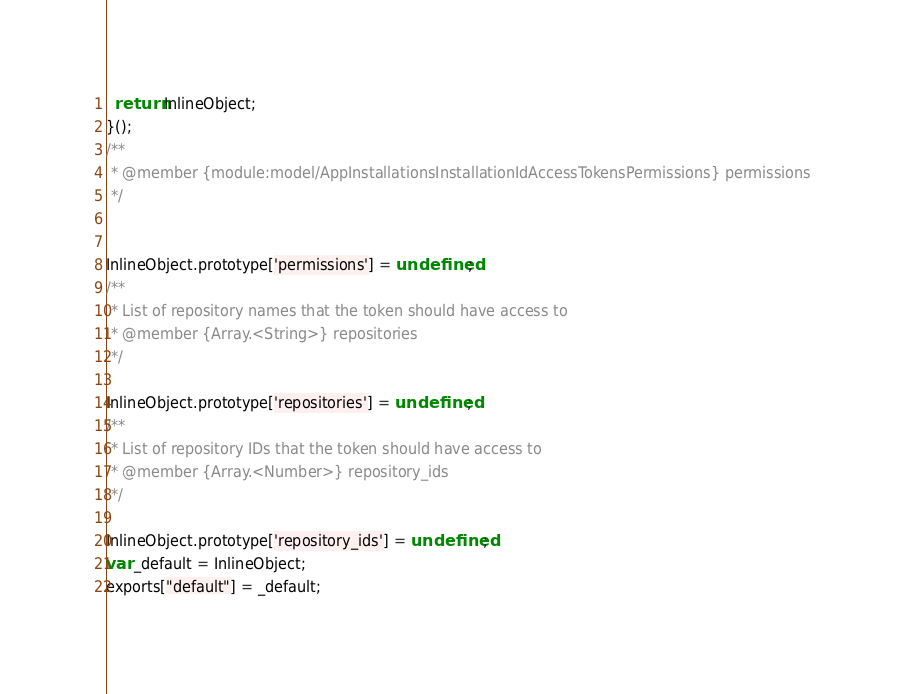Convert code to text. <code><loc_0><loc_0><loc_500><loc_500><_JavaScript_>
  return InlineObject;
}();
/**
 * @member {module:model/AppInstallationsInstallationIdAccessTokensPermissions} permissions
 */


InlineObject.prototype['permissions'] = undefined;
/**
 * List of repository names that the token should have access to
 * @member {Array.<String>} repositories
 */

InlineObject.prototype['repositories'] = undefined;
/**
 * List of repository IDs that the token should have access to
 * @member {Array.<Number>} repository_ids
 */

InlineObject.prototype['repository_ids'] = undefined;
var _default = InlineObject;
exports["default"] = _default;</code> 